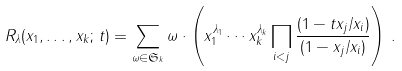<formula> <loc_0><loc_0><loc_500><loc_500>R _ { \lambda } ( x _ { 1 } , \dots , x _ { k } ; \, t ) = \sum _ { \omega \in \mathfrak { S } _ { k } } \omega \cdot \left ( x _ { 1 } ^ { \lambda _ { 1 } } \cdots x _ { k } ^ { \lambda _ { k } } \prod _ { i < j } \frac { ( 1 - t x _ { j } / x _ { i } ) } { ( 1 - x _ { j } / x _ { i } ) } \right ) \, .</formula> 